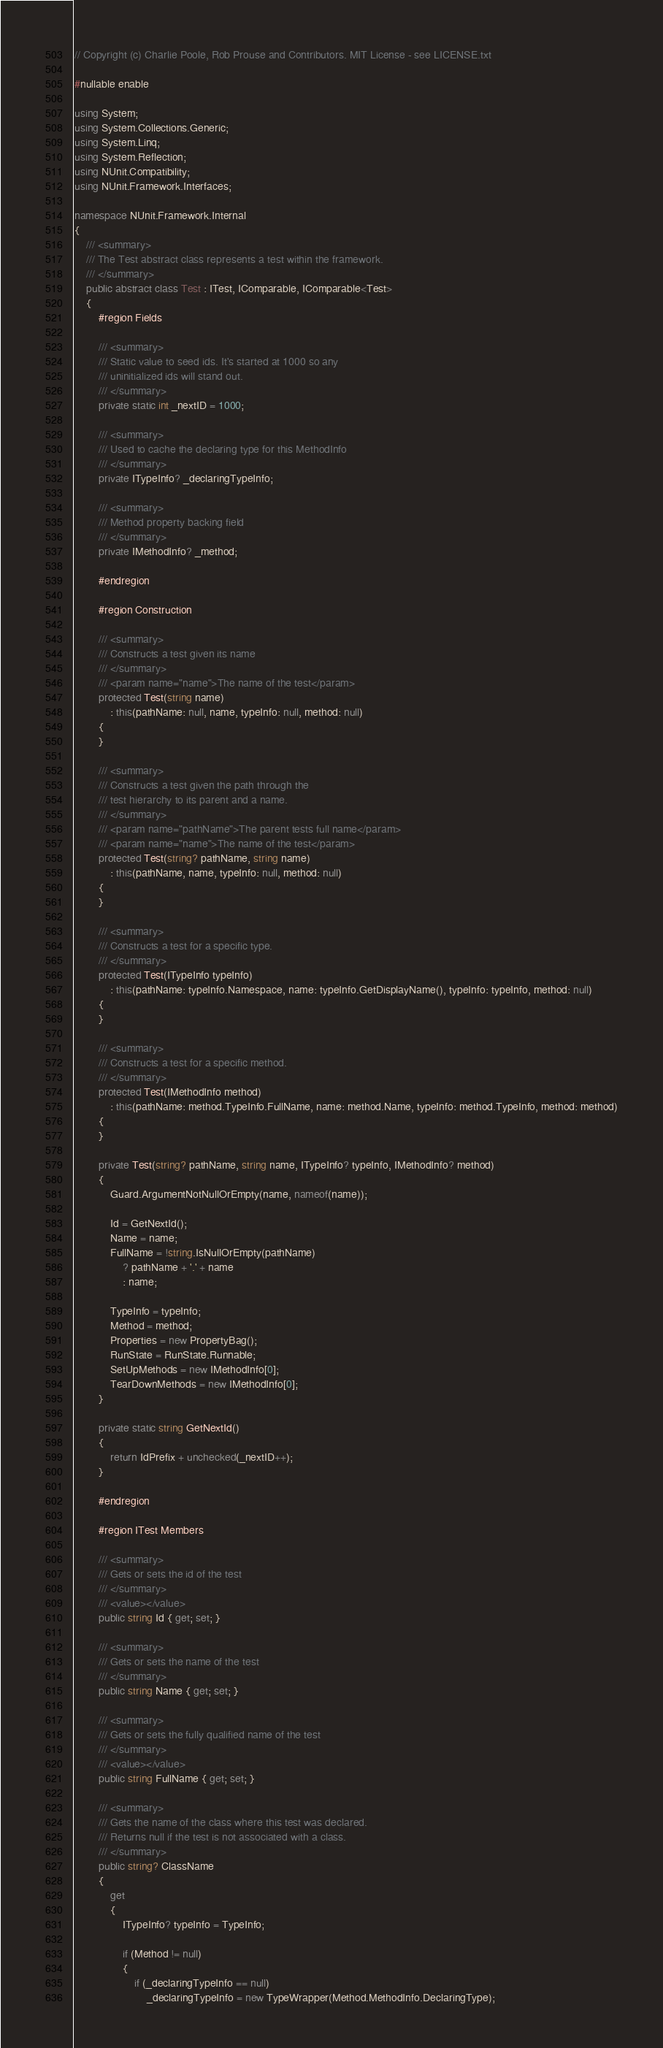<code> <loc_0><loc_0><loc_500><loc_500><_C#_>// Copyright (c) Charlie Poole, Rob Prouse and Contributors. MIT License - see LICENSE.txt

#nullable enable

using System;
using System.Collections.Generic;
using System.Linq;
using System.Reflection;
using NUnit.Compatibility;
using NUnit.Framework.Interfaces;

namespace NUnit.Framework.Internal
{
    /// <summary>
    /// The Test abstract class represents a test within the framework.
    /// </summary>
    public abstract class Test : ITest, IComparable, IComparable<Test>
    {
        #region Fields

        /// <summary>
        /// Static value to seed ids. It's started at 1000 so any
        /// uninitialized ids will stand out.
        /// </summary>
        private static int _nextID = 1000;

        /// <summary>
        /// Used to cache the declaring type for this MethodInfo
        /// </summary>
        private ITypeInfo? _declaringTypeInfo;

        /// <summary>
        /// Method property backing field
        /// </summary>
        private IMethodInfo? _method;

        #endregion

        #region Construction

        /// <summary>
        /// Constructs a test given its name
        /// </summary>
        /// <param name="name">The name of the test</param>
        protected Test(string name)
            : this(pathName: null, name, typeInfo: null, method: null)
        {
        }

        /// <summary>
        /// Constructs a test given the path through the
        /// test hierarchy to its parent and a name.
        /// </summary>
        /// <param name="pathName">The parent tests full name</param>
        /// <param name="name">The name of the test</param>
        protected Test(string? pathName, string name)
            : this(pathName, name, typeInfo: null, method: null)
        {
        }

        /// <summary>
        /// Constructs a test for a specific type.
        /// </summary>
        protected Test(ITypeInfo typeInfo)
            : this(pathName: typeInfo.Namespace, name: typeInfo.GetDisplayName(), typeInfo: typeInfo, method: null)
        {
        }

        /// <summary>
        /// Constructs a test for a specific method.
        /// </summary>
        protected Test(IMethodInfo method)
            : this(pathName: method.TypeInfo.FullName, name: method.Name, typeInfo: method.TypeInfo, method: method)
        {
        }

        private Test(string? pathName, string name, ITypeInfo? typeInfo, IMethodInfo? method)
        {
            Guard.ArgumentNotNullOrEmpty(name, nameof(name));

            Id = GetNextId();
            Name = name;
            FullName = !string.IsNullOrEmpty(pathName)
                ? pathName + '.' + name
                : name;

            TypeInfo = typeInfo;
            Method = method;
            Properties = new PropertyBag();
            RunState = RunState.Runnable;
            SetUpMethods = new IMethodInfo[0];
            TearDownMethods = new IMethodInfo[0];
        }

        private static string GetNextId()
        {
            return IdPrefix + unchecked(_nextID++);
        }

        #endregion

        #region ITest Members

        /// <summary>
        /// Gets or sets the id of the test
        /// </summary>
        /// <value></value>
        public string Id { get; set; }

        /// <summary>
        /// Gets or sets the name of the test
        /// </summary>
        public string Name { get; set; }

        /// <summary>
        /// Gets or sets the fully qualified name of the test
        /// </summary>
        /// <value></value>
        public string FullName { get; set; }

        /// <summary>
        /// Gets the name of the class where this test was declared.
        /// Returns null if the test is not associated with a class.
        /// </summary>
        public string? ClassName
        {
            get
            {
                ITypeInfo? typeInfo = TypeInfo;

                if (Method != null)
                {
                    if (_declaringTypeInfo == null)
                        _declaringTypeInfo = new TypeWrapper(Method.MethodInfo.DeclaringType);
</code> 